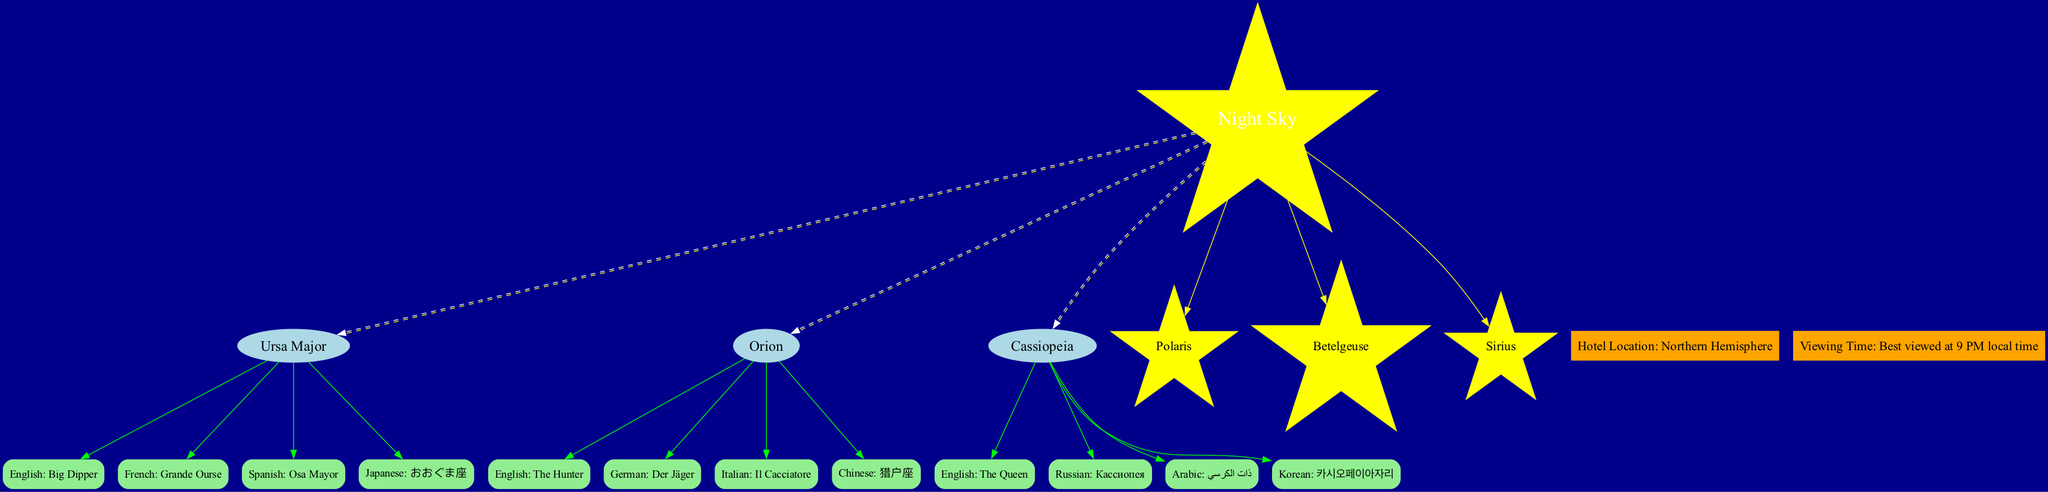What is the brightest star listed in the diagram? The brightest star according to the diagram is "Sirius," which is a separate node connected to the center "Night Sky."
Answer: Sirius How many constellations are shown in the diagram? The diagram lists three constellations: Ursa Major, Orion, and Cassiopeia. Counting these nodes gives a total of three.
Answer: 3 What is the language label for Orion in Italian? The diagram shows "Il Cacciatore" as the label for Orion in Italian, representing the specific text linked to the Orion node.
Answer: Il Cacciatore Which constellation has a label in Russian? "Кассиопея" is the Russian label for the constellation Cassiopeia, indicating the constellation node's connection to the Russian language label.
Answer: Cassiopeia What is the viewing time mentioned in the diagram? The viewing time is shown as "Best viewed at 9 PM local time," which is connected as a node beneath the center node.
Answer: 9 PM local time Which constellation is referred to as "The Queen"? The label "The Queen" corresponds to the constellation Cassiopeia, establishing the link between the label node and the constellation node.
Answer: Cassiopeia What is the hotel location stated in the diagram? The hotel location is labeled as "Hotel Location: Northern Hemisphere," found as a separate node connected to the center.
Answer: Northern Hemisphere Which two languages are used for the Big Dipper? The names for the Big Dipper in different languages shown are "Big Dipper" (English) and "Grande Ourse" (French).
Answer: Big Dipper, Grande Ourse How many language labels are connected to Orion? Orion has four language labels connected to it: English, German, Italian, and Chinese, giving a count of four language nodes linked to the Orion node.
Answer: 4 